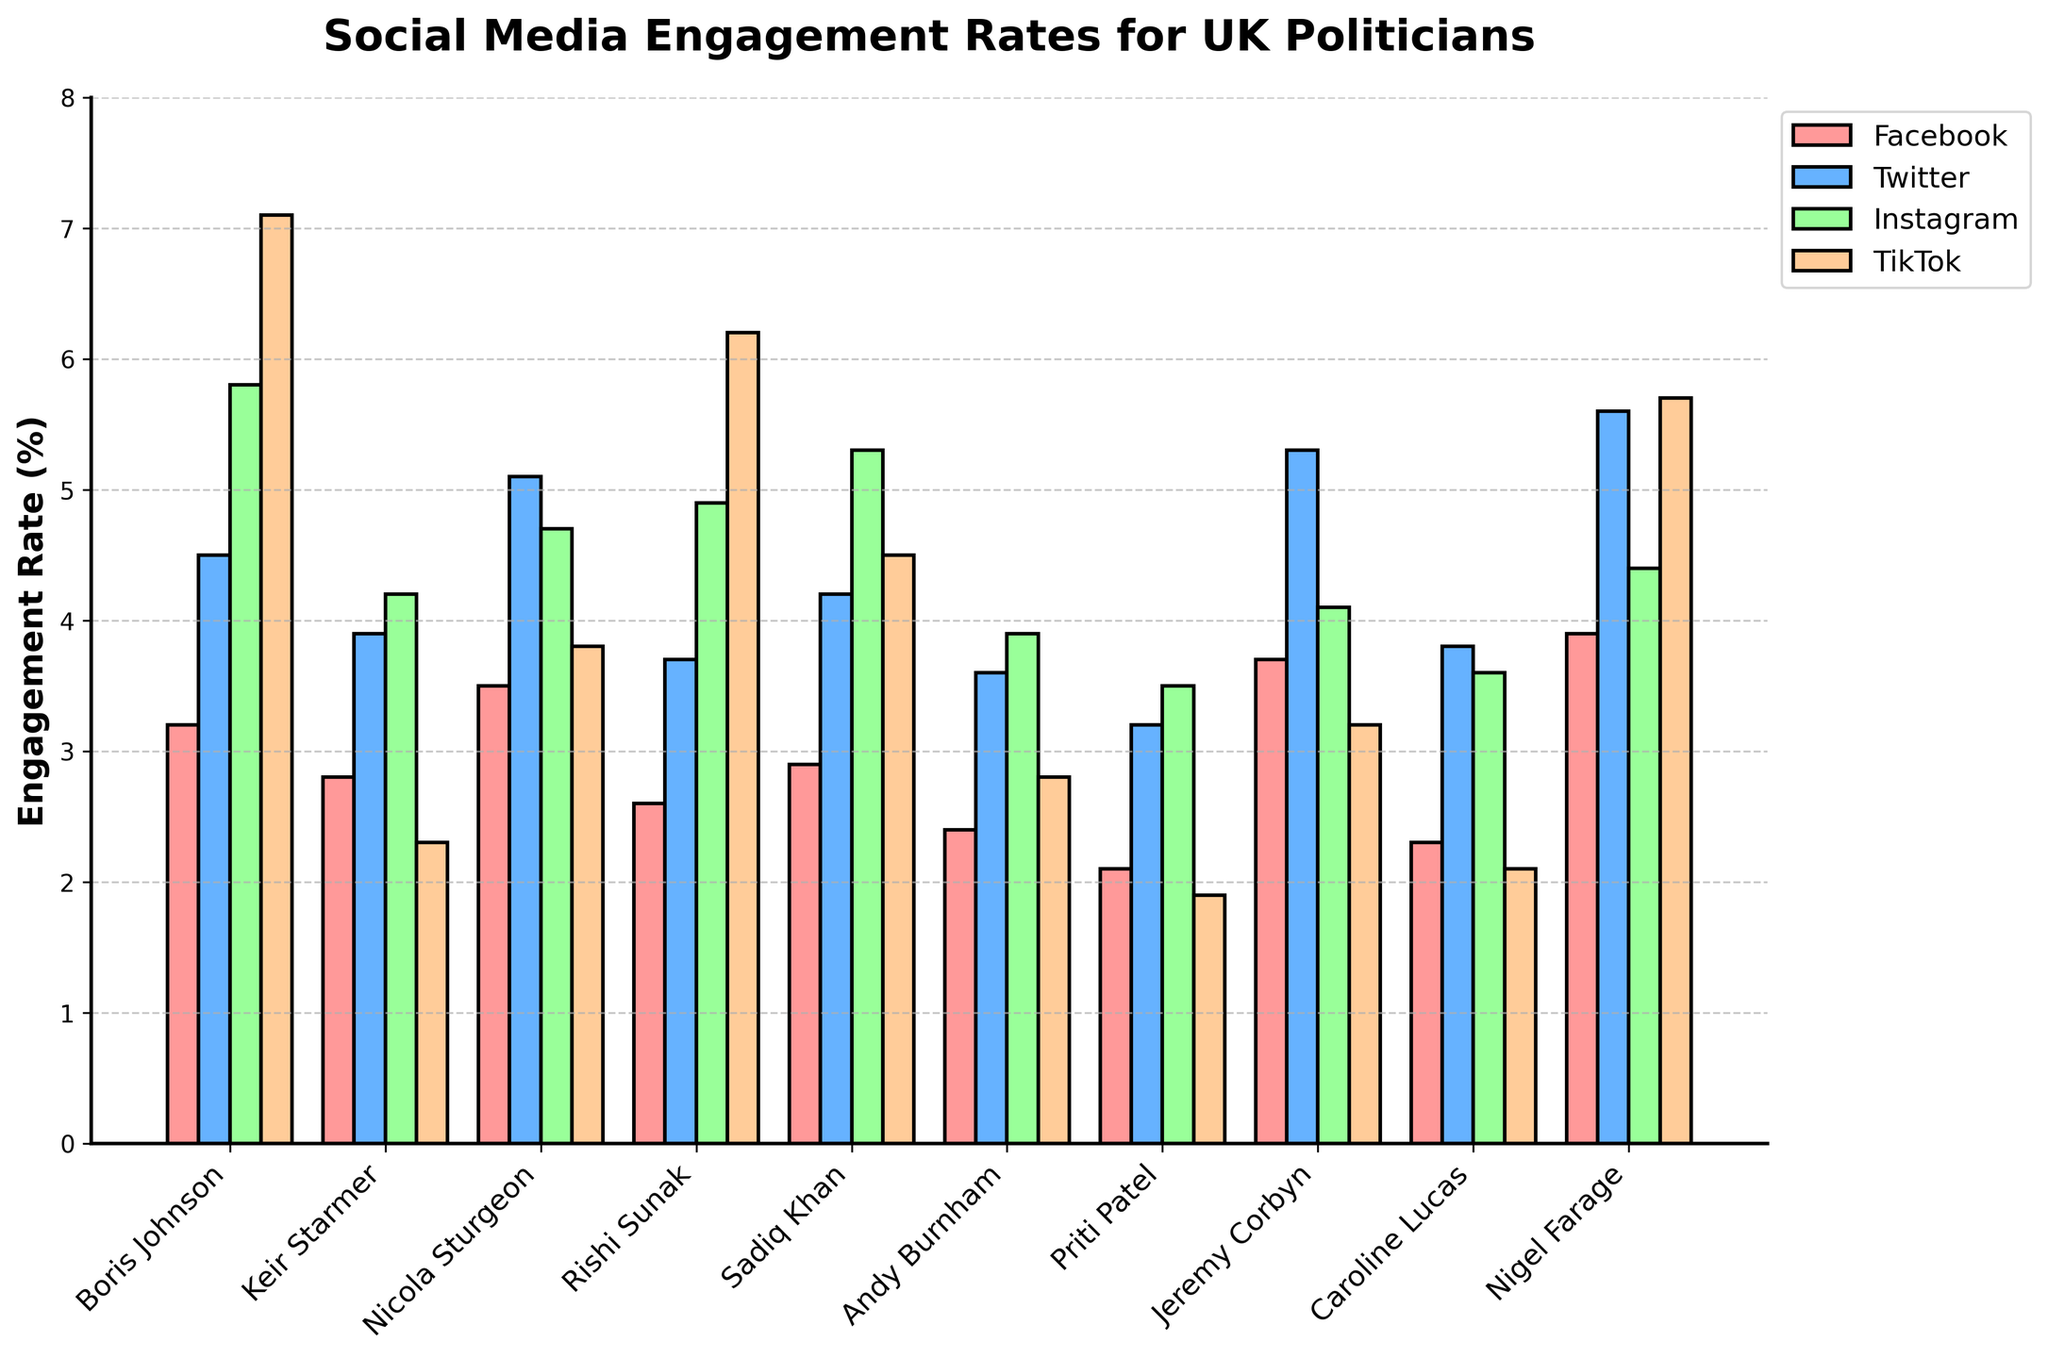Which politician has the highest engagement rate on Facebook? To find the politician with the highest engagement rate, look at the tallest bar in the "Facebook" category (the first set of bars). Based on the heights, it's Nigel Farage.
Answer: Nigel Farage Which social media platform has the highest engagement rate for Boris Johnson? For Boris Johnson, identify the tallest bar among his engagement rates across Facebook, Twitter, Instagram, and TikTok. The TikTok bar is the tallest.
Answer: TikTok Compare the Twitter engagement rates between Boris Johnson and Keir Starmer. Who has the higher rate? By looking at the "Twitter" engagement rates, compare the heights of the bars for Boris Johnson and Keir Starmer. Boris Johnson's bar is taller.
Answer: Boris Johnson What is the average engagement rate on Instagram for Sadiq Khan and Andy Burnham? First, find the Instagram engagement rates for Sadiq Khan (5.3%) and Andy Burnham (3.9%). Then, calculate the average: (5.3 + 3.9) / 2 = 4.6%.
Answer: 4.6% Which politician has the lowest engagement rate on TikTok? Look at the shortest bar in the "TikTok" category (the last set of bars). The shortest bar corresponds to Priti Patel.
Answer: Priti Patel How much higher is Jeremy Corbyn's Facebook engagement rate compared to Priti Patel's? Jeremy Corbyn's Facebook engagement rate is 3.7%, and Priti Patel's is 2.1%. The difference is calculated by 3.7 - 2.1 = 1.6%.
Answer: 1.6% Rank the politicians by their Twitter engagement rates from highest to lowest. Compare the heights of the bars in the "Twitter" category and rank them: 
1) Nigel Farage (5.6%), 
2) Jeremy Corbyn (5.3%),
3) Nicola Sturgeon (5.1%), 
4) Boris Johnson (4.5%), 
5) Sadiq Khan (4.2%), 
6) Keir Starmer (3.9%), 
7) Caroline Lucas (3.8%), 
8) Rishi Sunak (3.7%), 
9) Andy Burnham (3.6%), 
10) Priti Patel (3.2%).
Answer: Nigel Farage, Jeremy Corbyn, Nicola Sturgeon, Boris Johnson, Sadiq Khan, Keir Starmer, Caroline Lucas, Rishi Sunak, Andy Burnham, Priti Patel Which platform has the most consistent engagement rates across the politicians? Determine consistency by noting which platform has the least variation in bar heights across all politicians. Instagram bars appear to have the least variation in height.
Answer: Instagram What is the sum of Twitter and Facebook engagement rates for Caroline Lucas? The Twitter engagement rate for Caroline Lucas is 3.8%, and the Facebook engagement rate is 2.3%. Summing these up: 3.8% + 2.3% = 6.1%.
Answer: 6.1% Which politician shows the biggest difference between their highest and lowest engagement rates across all platforms? For each politician, find their highest and lowest engagement rates across Facebook, Twitter, Instagram, and TikTok, then calculate the differences:
- Boris Johnson: 7.1% (TikTok) - 3.2% (Facebook) = 3.9%
- Keir Starmer: 4.2% (Instagram) - 2.3% (TikTok) = 1.9%
- Nicola Sturgeon: 5.1% (Twitter) - 3.5% (Facebook) = 1.6%
- Rishi Sunak: 6.2% (TikTok) - 2.6% (Facebook) = 3.6%
- Sadiq Khan: 5.3% (Instagram) - 2.9% (Facebook) = 2.4%
- Andy Burnham: 3.9% (Instagram) - 2.4% (Facebook) = 1.5%
- Priti Patel: 3.5% (Instagram) - 1.9% (TikTok) = 1.6%
- Jeremy Corbyn: 5.3% (Twitter) - 3.2% (TikTok) = 2.1%
- Caroline Lucas: 3.8% (Twitter) - 2.1% (TikTok) = 1.7%
- Nigel Farage: 5.7% (TikTok) - 3.9% (Facebook) = 1.8%
Boris Johnson has the largest difference.
Answer: Boris Johnson 